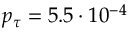<formula> <loc_0><loc_0><loc_500><loc_500>p _ { \tau } = 5 . 5 \cdot 1 0 ^ { - 4 }</formula> 